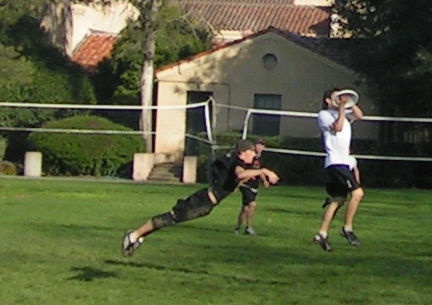Describe the objects in this image and their specific colors. I can see people in olive, black, white, gray, and darkgray tones, people in olive, black, darkgreen, gray, and tan tones, people in olive, black, gray, and darkgreen tones, and frisbee in olive, gray, darkgray, and lightgray tones in this image. 